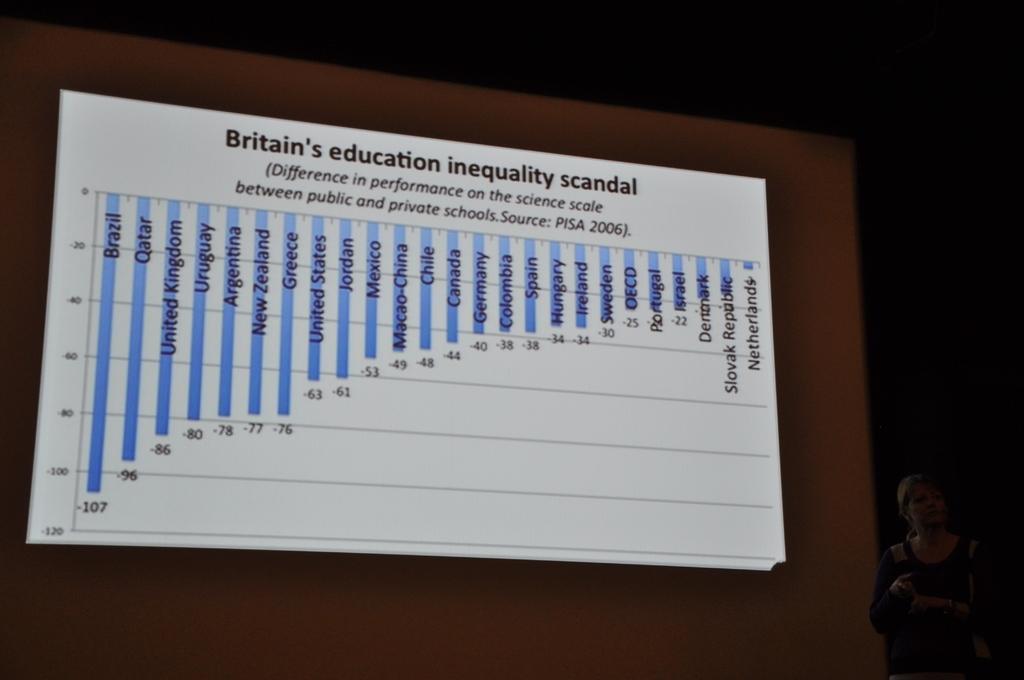In one or two sentences, can you explain what this image depicts? In this image, we can see a screen contains some statistics. There is a person in the bottom right of the image. 